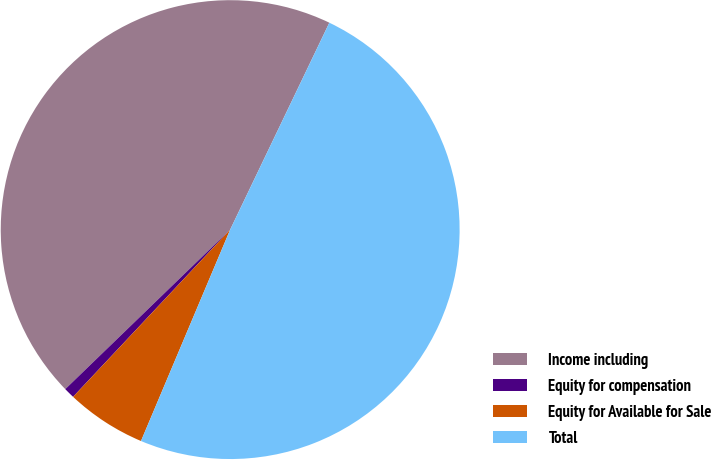Convert chart. <chart><loc_0><loc_0><loc_500><loc_500><pie_chart><fcel>Income including<fcel>Equity for compensation<fcel>Equity for Available for Sale<fcel>Total<nl><fcel>44.35%<fcel>0.76%<fcel>5.65%<fcel>49.24%<nl></chart> 